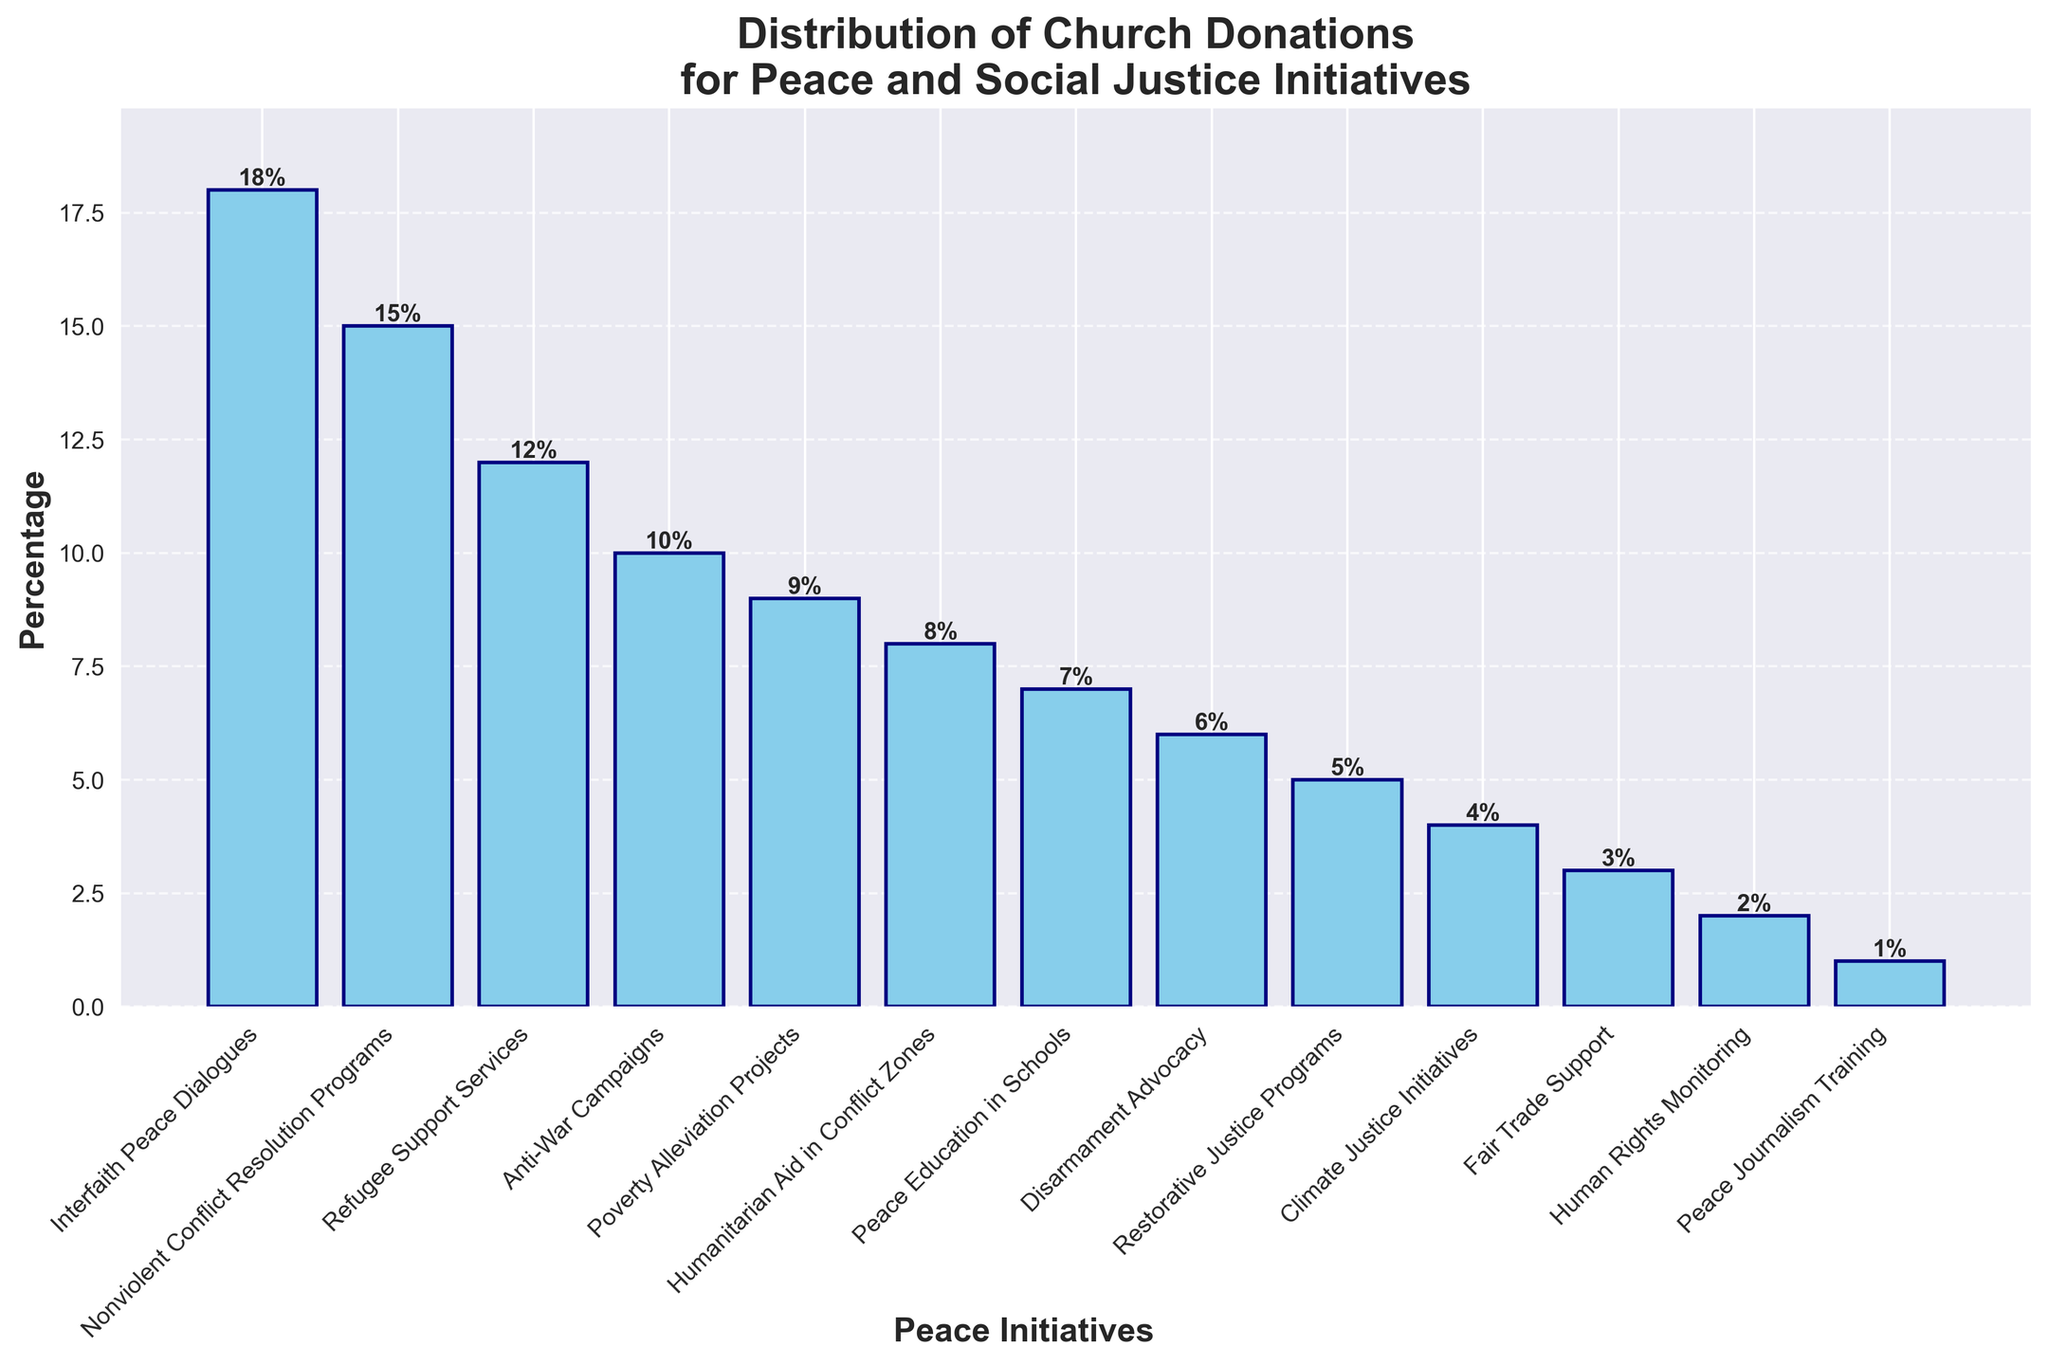Which initiative received the highest percentage of church donations? The initiative with the tallest bar represents the highest percentage. From the chart, "Interfaith Peace Dialogues" received the highest percentage.
Answer: Interfaith Peace Dialogues Which initiative received the lowest percentage of church donations? The initiative with the shortest bar represents the lowest percentage. From the chart, "Peace Journalism Training" received the lowest percentage.
Answer: Peace Journalism Training What is the combined percentage of donations allocated to "Humanitarian Aid in Conflict Zones" and "Peace Education in Schools"? Combine the values of the two initiatives: 8% for "Humanitarian Aid in Conflict Zones" and 7% for "Peace Education in Schools". 8 + 7 = 15.
Answer: 15 How does the percentage of donations for "Poverty Alleviation Projects" compare to "Anti-War Campaigns"? Compare the heights of the two bars. "Poverty Alleviation Projects" is at 9% and "Anti-War Campaigns" is at 10%. 9 is less than 10.
Answer: Less What is the average percentage of donations for "Disarmament Advocacy", "Restorative Justice Programs", and "Climate Justice Initiatives"? Sum the values and divide by the number of initiatives: (6 + 5 + 4) / 3 = 15 / 3 = 5.
Answer: 5 Which initiative received donations 3% higher than "Nonviolent Conflict Resolution Programs"? "Nonviolent Conflict Resolution Programs" received 15%. Adding 3% gives us 18%. The initiative at 18% is "Interfaith Peace Dialogues".
Answer: Interfaith Peace Dialogues What is the difference in percentage between the highest and lowest funded initiatives? Subtract the value of the shortest bar from the value of the tallest bar. 18% (highest) - 1% (lowest) = 17%.
Answer: 17 Are donations to "Refugee Support Services" greater than those to "Humanitarian Aid in Conflict Zones" and "Peace Education in Schools" combined? "Refugee Support Services" received 12%. "Humanitarian Aid in Conflict Zones" and "Peace Education in Schools" combined is 8% + 7% = 15%. 12% is less than 15%.
Answer: No Which initiatives received less than 5% of the total donations? Initiatives with bars shorter than the 5% line are "Climate Justice Initiatives" (4%), "Fair Trade Support" (3%), "Human Rights Monitoring" (2%), and "Peace Journalism Training" (1%).
Answer: Climate Justice Initiatives, Fair Trade Support, Human Rights Monitoring, Peace Journalism Training 